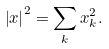Convert formula to latex. <formula><loc_0><loc_0><loc_500><loc_500>\left | x \right | ^ { 2 } = \sum _ { k } x _ { k } ^ { 2 } .</formula> 